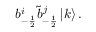Convert formula to latex. <formula><loc_0><loc_0><loc_500><loc_500>b _ { - \frac { 1 } { 2 } } ^ { i } \tilde { b } _ { - \frac { 1 } { 2 } } ^ { j } \left | k \right > .</formula> 